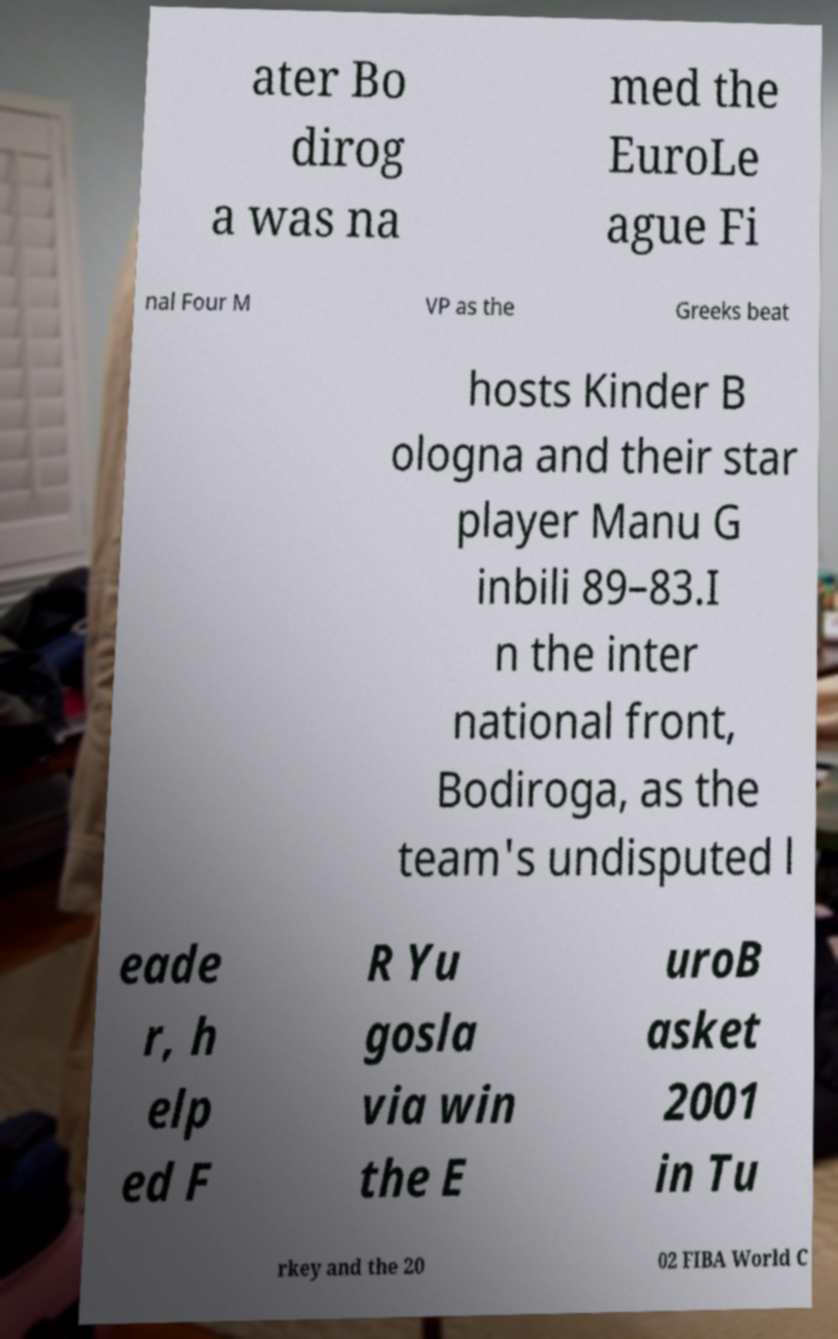What messages or text are displayed in this image? I need them in a readable, typed format. ater Bo dirog a was na med the EuroLe ague Fi nal Four M VP as the Greeks beat hosts Kinder B ologna and their star player Manu G inbili 89–83.I n the inter national front, Bodiroga, as the team's undisputed l eade r, h elp ed F R Yu gosla via win the E uroB asket 2001 in Tu rkey and the 20 02 FIBA World C 